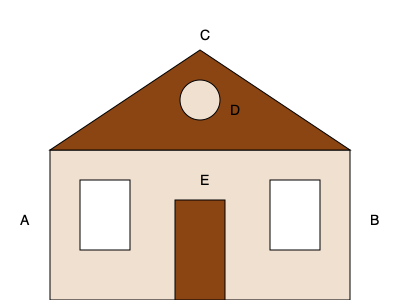Identifiez les éléments architecturaux d'un château français en associant les lettres aux termes corrects : tour, toit, fenêtre, porte principale, mur. Quelle est la lettre qui correspond à la "porte principale" ? Pour identifier la porte principale d'un château français, suivons ces étapes :

1. Analysons chaque élément marqué d'une lettre :
   A et B : Ces éléments sont des ouvertures rectangulaires dans le mur, typiques des fenêtres.
   C : Cet élément triangulaire au sommet représente le toit du château.
   D : Cette forme circulaire pourrait être une petite tour ou une tourelle décorative.
   E : Cet élément rectangulaire au centre du mur, plus grand que les fenêtres, représente la porte principale.

2. La porte principale d'un château français est généralement :
   - Centrée sur la façade
   - Plus grande que les fenêtres
   - Située au niveau du sol

3. L'élément E correspond à tous ces critères :
   - Il est au centre de la façade
   - Il est plus grand que les éléments A et B (les fenêtres)
   - Il est situé au niveau inférieur du château

Donc, la lettre qui correspond à la "porte principale" est E.
Answer: E 